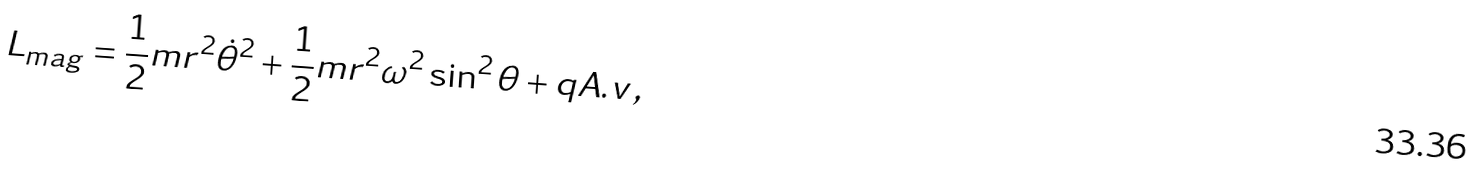<formula> <loc_0><loc_0><loc_500><loc_500>L _ { m a g } = \frac { 1 } { 2 } m r ^ { 2 } { \dot { \theta } } ^ { 2 } + \frac { 1 } { 2 } m r ^ { 2 } \omega ^ { 2 } \sin ^ { 2 } \theta + q { A . v } \, ,</formula> 